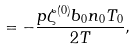<formula> <loc_0><loc_0><loc_500><loc_500>= - \frac { p \zeta ^ { ( 0 ) } b _ { 0 } n _ { 0 } T _ { 0 } } { 2 T } ,</formula> 